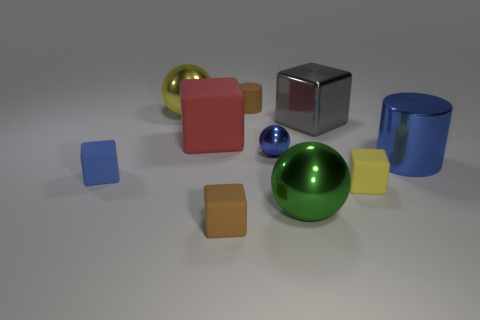How many other objects are the same color as the small ball?
Provide a short and direct response. 2. What number of large yellow things have the same shape as the tiny shiny thing?
Give a very brief answer. 1. Is the number of brown matte things that are on the right side of the small blue shiny sphere less than the number of large red objects that are on the right side of the yellow metallic object?
Your response must be concise. Yes. How many shiny objects are behind the shiny sphere in front of the metal cylinder?
Keep it short and to the point. 4. Are there any red things?
Ensure brevity in your answer.  Yes. Is there a small brown cylinder made of the same material as the blue block?
Provide a short and direct response. Yes. Are there more large cubes in front of the big yellow object than large gray metal objects left of the gray metallic object?
Make the answer very short. Yes. Is the size of the yellow cube the same as the blue ball?
Your response must be concise. Yes. The cylinder on the right side of the yellow thing right of the big matte object is what color?
Your response must be concise. Blue. What is the color of the metal cylinder?
Provide a succinct answer. Blue. 